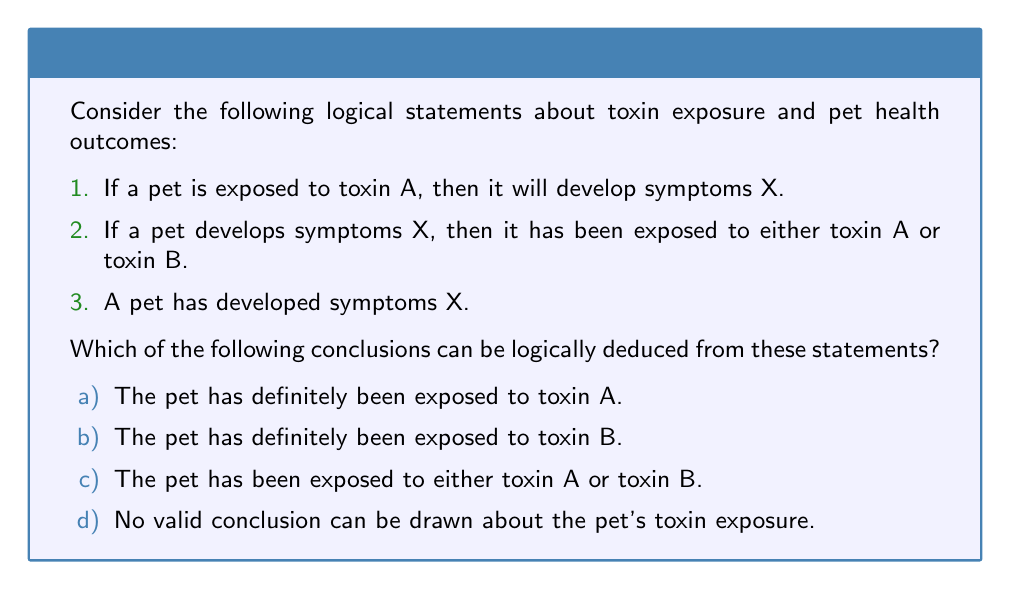Provide a solution to this math problem. Let's analyze this problem using propositional logic:

Let:
A = "Pet is exposed to toxin A"
B = "Pet is exposed to toxin B"
X = "Pet develops symptoms X"

The given statements can be translated into logical expressions:

1. $A \implies X$ (If A, then X)
2. $X \implies (A \lor B)$ (If X, then A or B)
3. X (Pet has developed symptoms X)

Now, let's evaluate each conclusion:

a) We cannot conclude that the pet has definitely been exposed to toxin A. While we know $A \implies X$, we cannot infer $X \implies A$. This would be the fallacy of affirming the consequent.

b) We cannot conclude that the pet has definitely been exposed to toxin B. We only know that X implies either A or B, not specifically B.

c) This conclusion is valid. We can deduce this using the following steps:
   - We know X is true (given in statement 3)
   - From statement 2, we know $X \implies (A \lor B)$
   - Using modus ponens, we can conclude $A \lor B$ is true

d) This is not correct because we can draw a valid conclusion as shown in (c).

Therefore, the logically valid conclusion is (c): The pet has been exposed to either toxin A or toxin B.

This conclusion aligns with the toxicologist's need to consider multiple possible toxin exposures when observing specific symptoms in pets.
Answer: c) The pet has been exposed to either toxin A or toxin B. 